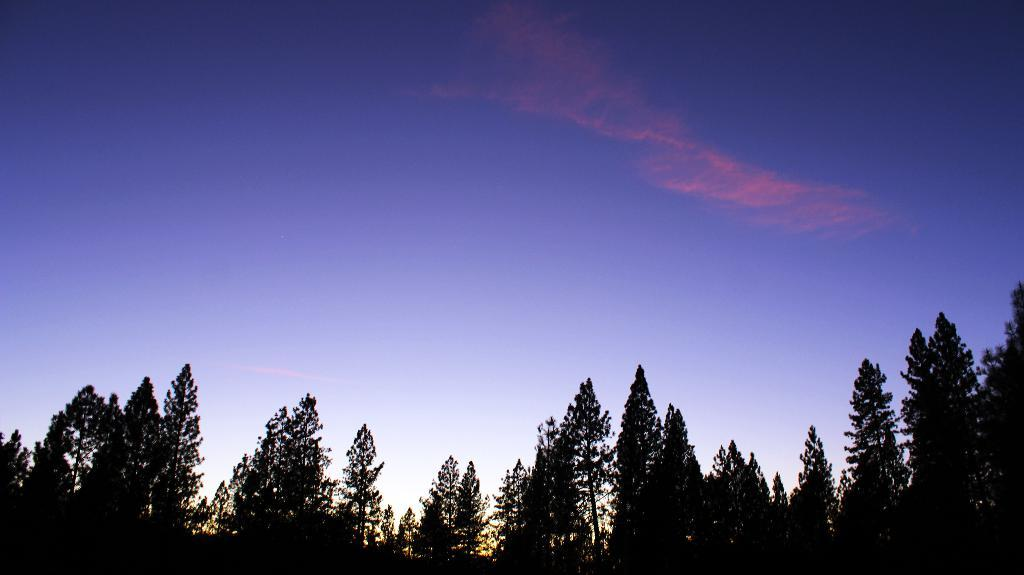What can be seen at the top of the image? The sky is visible in the image. What type of vegetation is present in the image? There are trees in the image. How much wealth does the sister have in the image? There is no mention of a sister or wealth in the image, so it is not possible to answer that question. 